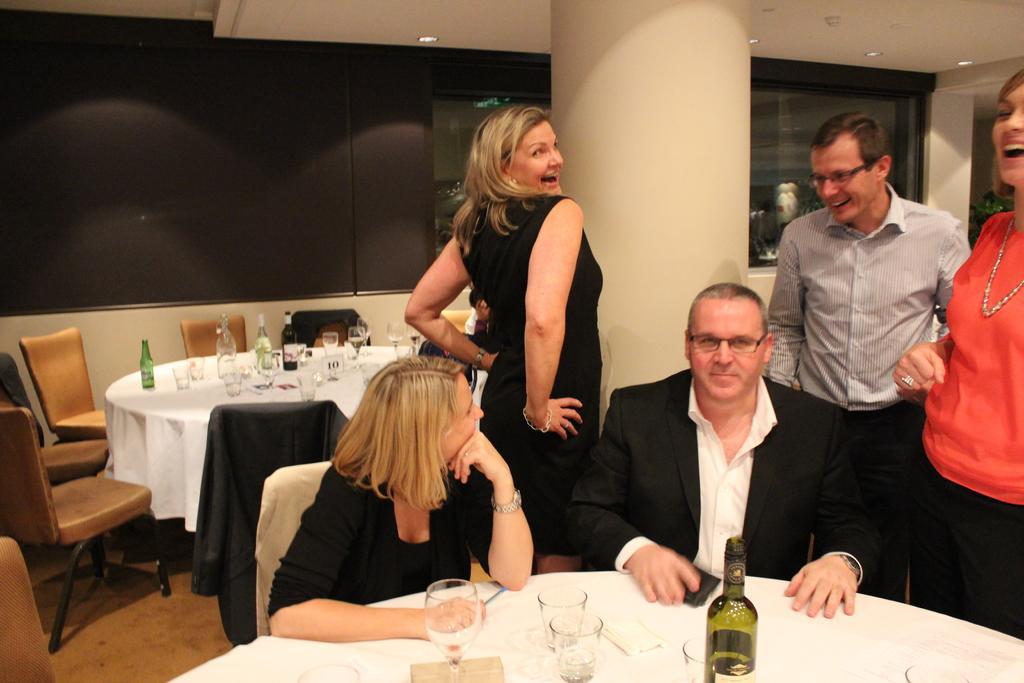Could you give a brief overview of what you see in this image? In this picture we can see some people are sitting on the chair and some people are standing they are talking to each other in front of them there is a table which is covered with white in cloth on the table we have bottle glasses tissues and back side we have so many child and table. 